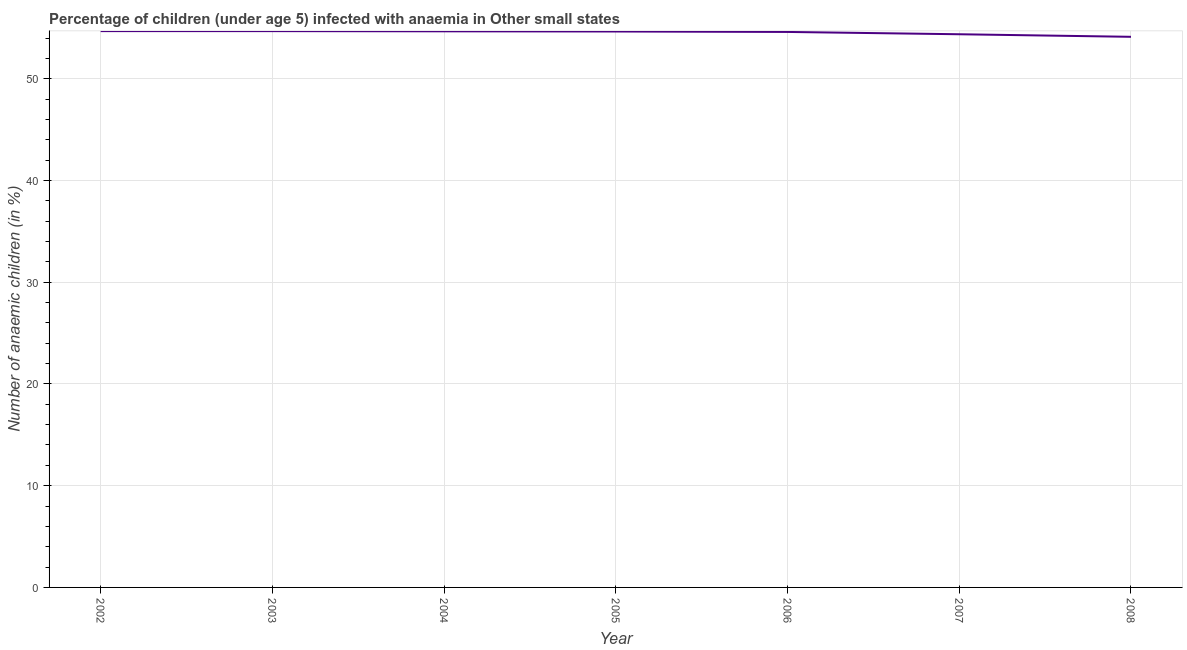What is the number of anaemic children in 2007?
Make the answer very short. 54.37. Across all years, what is the maximum number of anaemic children?
Provide a short and direct response. 54.68. Across all years, what is the minimum number of anaemic children?
Offer a very short reply. 54.12. In which year was the number of anaemic children maximum?
Your answer should be compact. 2002. What is the sum of the number of anaemic children?
Offer a very short reply. 381.76. What is the difference between the number of anaemic children in 2002 and 2005?
Make the answer very short. 0.04. What is the average number of anaemic children per year?
Offer a very short reply. 54.54. What is the median number of anaemic children?
Your answer should be compact. 54.64. In how many years, is the number of anaemic children greater than 10 %?
Offer a very short reply. 7. Do a majority of the years between 2006 and 2004 (inclusive) have number of anaemic children greater than 26 %?
Ensure brevity in your answer.  No. What is the ratio of the number of anaemic children in 2006 to that in 2008?
Your answer should be compact. 1.01. Is the number of anaemic children in 2002 less than that in 2004?
Your answer should be very brief. No. Is the difference between the number of anaemic children in 2007 and 2008 greater than the difference between any two years?
Your response must be concise. No. What is the difference between the highest and the second highest number of anaemic children?
Provide a succinct answer. 0. What is the difference between the highest and the lowest number of anaemic children?
Your answer should be compact. 0.56. In how many years, is the number of anaemic children greater than the average number of anaemic children taken over all years?
Keep it short and to the point. 5. Does the graph contain grids?
Your answer should be compact. Yes. What is the title of the graph?
Offer a terse response. Percentage of children (under age 5) infected with anaemia in Other small states. What is the label or title of the Y-axis?
Keep it short and to the point. Number of anaemic children (in %). What is the Number of anaemic children (in %) in 2002?
Provide a succinct answer. 54.68. What is the Number of anaemic children (in %) of 2003?
Your response must be concise. 54.68. What is the Number of anaemic children (in %) of 2004?
Your answer should be very brief. 54.66. What is the Number of anaemic children (in %) in 2005?
Keep it short and to the point. 54.64. What is the Number of anaemic children (in %) of 2006?
Your answer should be compact. 54.6. What is the Number of anaemic children (in %) in 2007?
Offer a very short reply. 54.37. What is the Number of anaemic children (in %) of 2008?
Make the answer very short. 54.12. What is the difference between the Number of anaemic children (in %) in 2002 and 2003?
Your response must be concise. 0. What is the difference between the Number of anaemic children (in %) in 2002 and 2004?
Keep it short and to the point. 0.02. What is the difference between the Number of anaemic children (in %) in 2002 and 2005?
Your answer should be very brief. 0.04. What is the difference between the Number of anaemic children (in %) in 2002 and 2006?
Offer a terse response. 0.08. What is the difference between the Number of anaemic children (in %) in 2002 and 2007?
Give a very brief answer. 0.31. What is the difference between the Number of anaemic children (in %) in 2002 and 2008?
Provide a succinct answer. 0.56. What is the difference between the Number of anaemic children (in %) in 2003 and 2004?
Your answer should be compact. 0.02. What is the difference between the Number of anaemic children (in %) in 2003 and 2005?
Give a very brief answer. 0.04. What is the difference between the Number of anaemic children (in %) in 2003 and 2006?
Provide a succinct answer. 0.08. What is the difference between the Number of anaemic children (in %) in 2003 and 2007?
Provide a short and direct response. 0.31. What is the difference between the Number of anaemic children (in %) in 2003 and 2008?
Your answer should be compact. 0.56. What is the difference between the Number of anaemic children (in %) in 2004 and 2005?
Give a very brief answer. 0.02. What is the difference between the Number of anaemic children (in %) in 2004 and 2006?
Give a very brief answer. 0.06. What is the difference between the Number of anaemic children (in %) in 2004 and 2007?
Provide a short and direct response. 0.29. What is the difference between the Number of anaemic children (in %) in 2004 and 2008?
Offer a very short reply. 0.54. What is the difference between the Number of anaemic children (in %) in 2005 and 2006?
Provide a succinct answer. 0.04. What is the difference between the Number of anaemic children (in %) in 2005 and 2007?
Make the answer very short. 0.27. What is the difference between the Number of anaemic children (in %) in 2005 and 2008?
Keep it short and to the point. 0.52. What is the difference between the Number of anaemic children (in %) in 2006 and 2007?
Provide a short and direct response. 0.23. What is the difference between the Number of anaemic children (in %) in 2006 and 2008?
Your answer should be compact. 0.48. What is the difference between the Number of anaemic children (in %) in 2007 and 2008?
Keep it short and to the point. 0.25. What is the ratio of the Number of anaemic children (in %) in 2002 to that in 2003?
Your response must be concise. 1. What is the ratio of the Number of anaemic children (in %) in 2002 to that in 2005?
Make the answer very short. 1. What is the ratio of the Number of anaemic children (in %) in 2002 to that in 2007?
Offer a very short reply. 1.01. What is the ratio of the Number of anaemic children (in %) in 2002 to that in 2008?
Your answer should be very brief. 1.01. What is the ratio of the Number of anaemic children (in %) in 2003 to that in 2004?
Offer a very short reply. 1. What is the ratio of the Number of anaemic children (in %) in 2003 to that in 2006?
Offer a very short reply. 1. What is the ratio of the Number of anaemic children (in %) in 2003 to that in 2007?
Ensure brevity in your answer.  1.01. What is the ratio of the Number of anaemic children (in %) in 2004 to that in 2006?
Give a very brief answer. 1. What is the ratio of the Number of anaemic children (in %) in 2004 to that in 2007?
Ensure brevity in your answer.  1. What is the ratio of the Number of anaemic children (in %) in 2004 to that in 2008?
Provide a succinct answer. 1.01. What is the ratio of the Number of anaemic children (in %) in 2006 to that in 2007?
Keep it short and to the point. 1. 